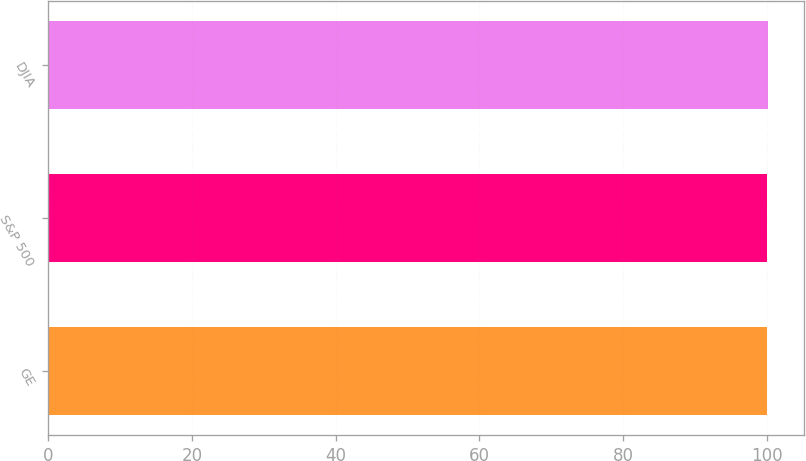<chart> <loc_0><loc_0><loc_500><loc_500><bar_chart><fcel>GE<fcel>S&P 500<fcel>DJIA<nl><fcel>100<fcel>100.1<fcel>100.2<nl></chart> 